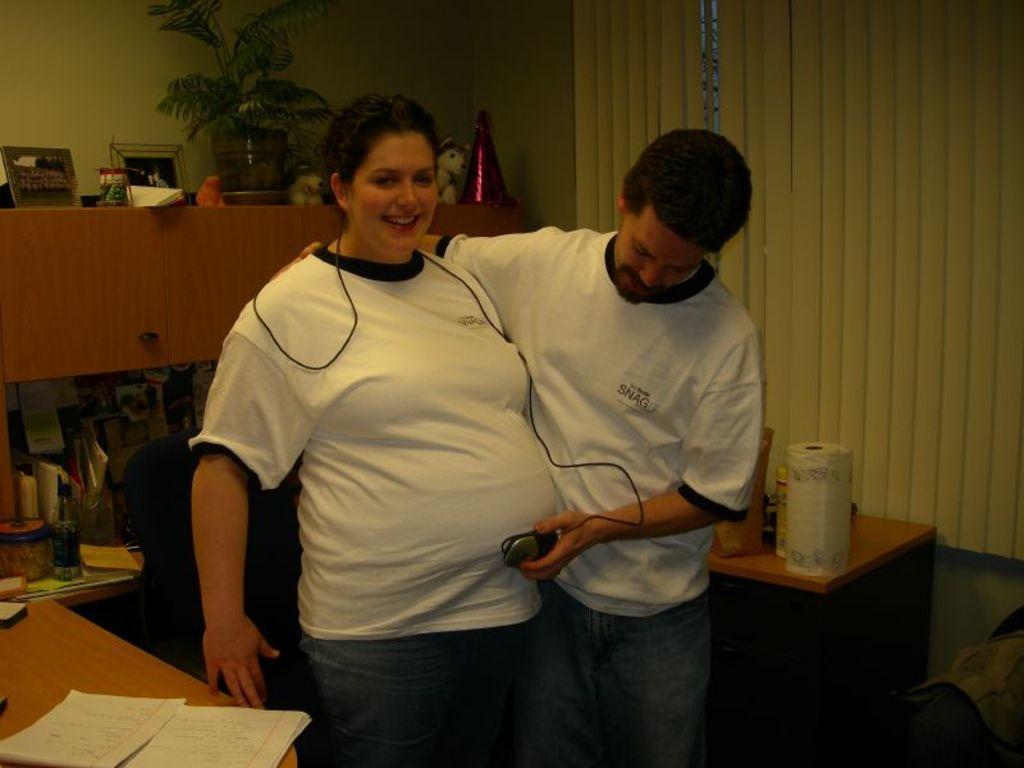Please provide a concise description of this image. In this image i can see a woman and a man wearing white t shirt and blue jeans, a man is holding an object in his hand. In the background i can see the window blind, a plant, a doll and a table on which there are few papers and few other objects. 